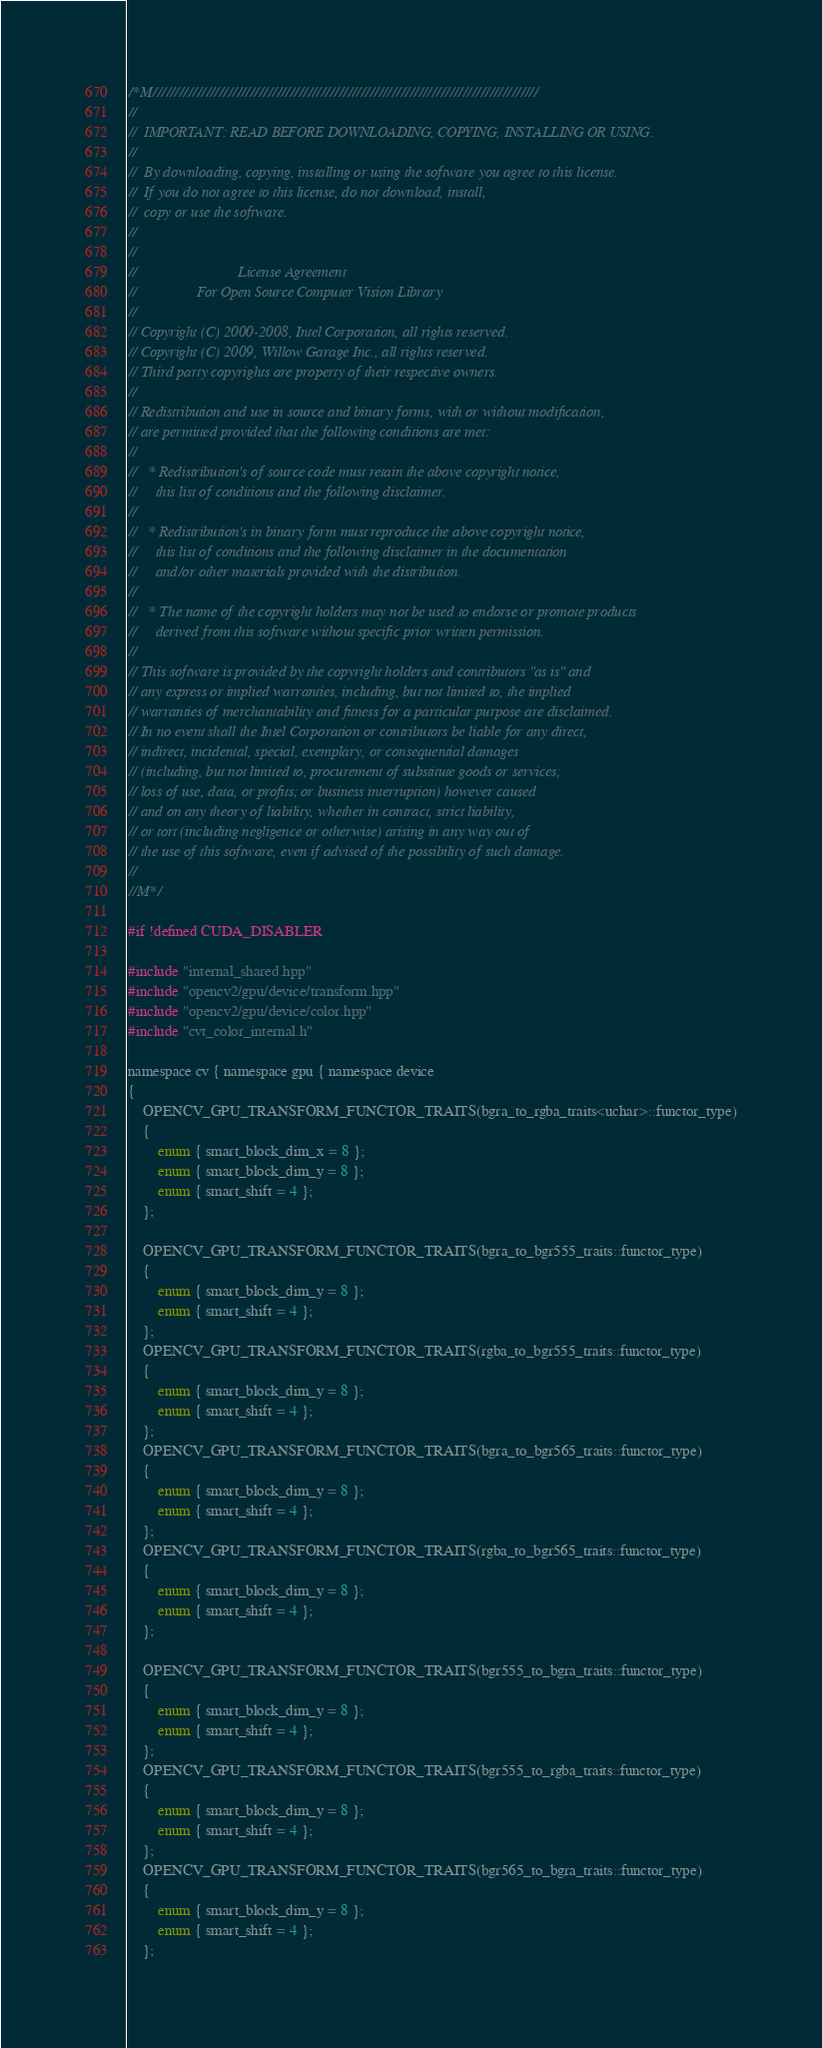<code> <loc_0><loc_0><loc_500><loc_500><_Cuda_>/*M///////////////////////////////////////////////////////////////////////////////////////
//
//  IMPORTANT: READ BEFORE DOWNLOADING, COPYING, INSTALLING OR USING.
//
//  By downloading, copying, installing or using the software you agree to this license.
//  If you do not agree to this license, do not download, install,
//  copy or use the software.
//
//
//                           License Agreement
//                For Open Source Computer Vision Library
//
// Copyright (C) 2000-2008, Intel Corporation, all rights reserved.
// Copyright (C) 2009, Willow Garage Inc., all rights reserved.
// Third party copyrights are property of their respective owners.
//
// Redistribution and use in source and binary forms, with or without modification,
// are permitted provided that the following conditions are met:
//
//   * Redistribution's of source code must retain the above copyright notice,
//     this list of conditions and the following disclaimer.
//
//   * Redistribution's in binary form must reproduce the above copyright notice,
//     this list of conditions and the following disclaimer in the documentation
//     and/or other materials provided with the distribution.
//
//   * The name of the copyright holders may not be used to endorse or promote products
//     derived from this software without specific prior written permission.
//
// This software is provided by the copyright holders and contributors "as is" and
// any express or implied warranties, including, but not limited to, the implied
// warranties of merchantability and fitness for a particular purpose are disclaimed.
// In no event shall the Intel Corporation or contributors be liable for any direct,
// indirect, incidental, special, exemplary, or consequential damages
// (including, but not limited to, procurement of substitute goods or services;
// loss of use, data, or profits; or business interruption) however caused
// and on any theory of liability, whether in contract, strict liability,
// or tort (including negligence or otherwise) arising in any way out of
// the use of this software, even if advised of the possibility of such damage.
//
//M*/

#if !defined CUDA_DISABLER

#include "internal_shared.hpp"
#include "opencv2/gpu/device/transform.hpp"
#include "opencv2/gpu/device/color.hpp"
#include "cvt_color_internal.h"

namespace cv { namespace gpu { namespace device
{
    OPENCV_GPU_TRANSFORM_FUNCTOR_TRAITS(bgra_to_rgba_traits<uchar>::functor_type)
    {
        enum { smart_block_dim_x = 8 };
        enum { smart_block_dim_y = 8 };
        enum { smart_shift = 4 };
    };

    OPENCV_GPU_TRANSFORM_FUNCTOR_TRAITS(bgra_to_bgr555_traits::functor_type)
    {
        enum { smart_block_dim_y = 8 };
        enum { smart_shift = 4 };
    };
    OPENCV_GPU_TRANSFORM_FUNCTOR_TRAITS(rgba_to_bgr555_traits::functor_type)
    {
        enum { smart_block_dim_y = 8 };
        enum { smart_shift = 4 };
    };
    OPENCV_GPU_TRANSFORM_FUNCTOR_TRAITS(bgra_to_bgr565_traits::functor_type)
    {
        enum { smart_block_dim_y = 8 };
        enum { smart_shift = 4 };
    };
    OPENCV_GPU_TRANSFORM_FUNCTOR_TRAITS(rgba_to_bgr565_traits::functor_type)
    {
        enum { smart_block_dim_y = 8 };
        enum { smart_shift = 4 };
    };

    OPENCV_GPU_TRANSFORM_FUNCTOR_TRAITS(bgr555_to_bgra_traits::functor_type)
    {
        enum { smart_block_dim_y = 8 };
        enum { smart_shift = 4 };
    };
    OPENCV_GPU_TRANSFORM_FUNCTOR_TRAITS(bgr555_to_rgba_traits::functor_type)
    {
        enum { smart_block_dim_y = 8 };
        enum { smart_shift = 4 };
    };
    OPENCV_GPU_TRANSFORM_FUNCTOR_TRAITS(bgr565_to_bgra_traits::functor_type)
    {
        enum { smart_block_dim_y = 8 };
        enum { smart_shift = 4 };
    };</code> 